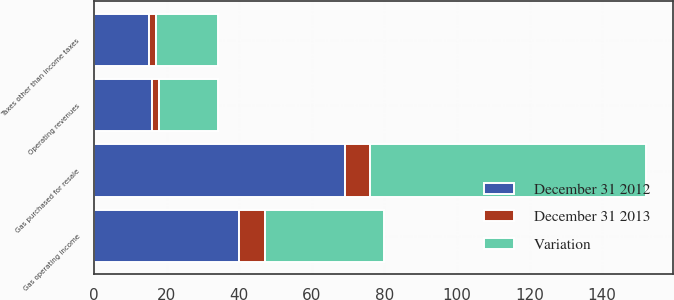Convert chart to OTSL. <chart><loc_0><loc_0><loc_500><loc_500><stacked_bar_chart><ecel><fcel>Operating revenues<fcel>Gas purchased for resale<fcel>Taxes other than income taxes<fcel>Gas operating income<nl><fcel>Variation<fcel>16<fcel>76<fcel>17<fcel>33<nl><fcel>December 31 2012<fcel>16<fcel>69<fcel>15<fcel>40<nl><fcel>December 31 2013<fcel>2<fcel>7<fcel>2<fcel>7<nl></chart> 